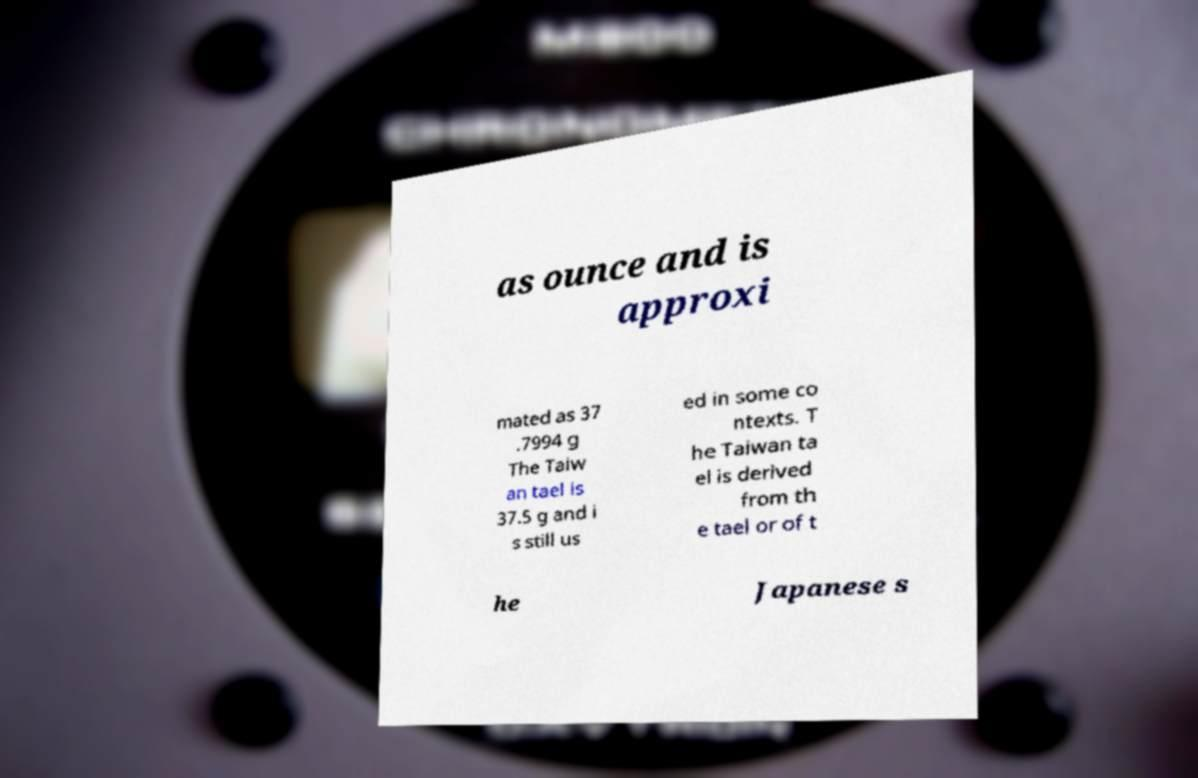Please identify and transcribe the text found in this image. as ounce and is approxi mated as 37 .7994 g The Taiw an tael is 37.5 g and i s still us ed in some co ntexts. T he Taiwan ta el is derived from th e tael or of t he Japanese s 